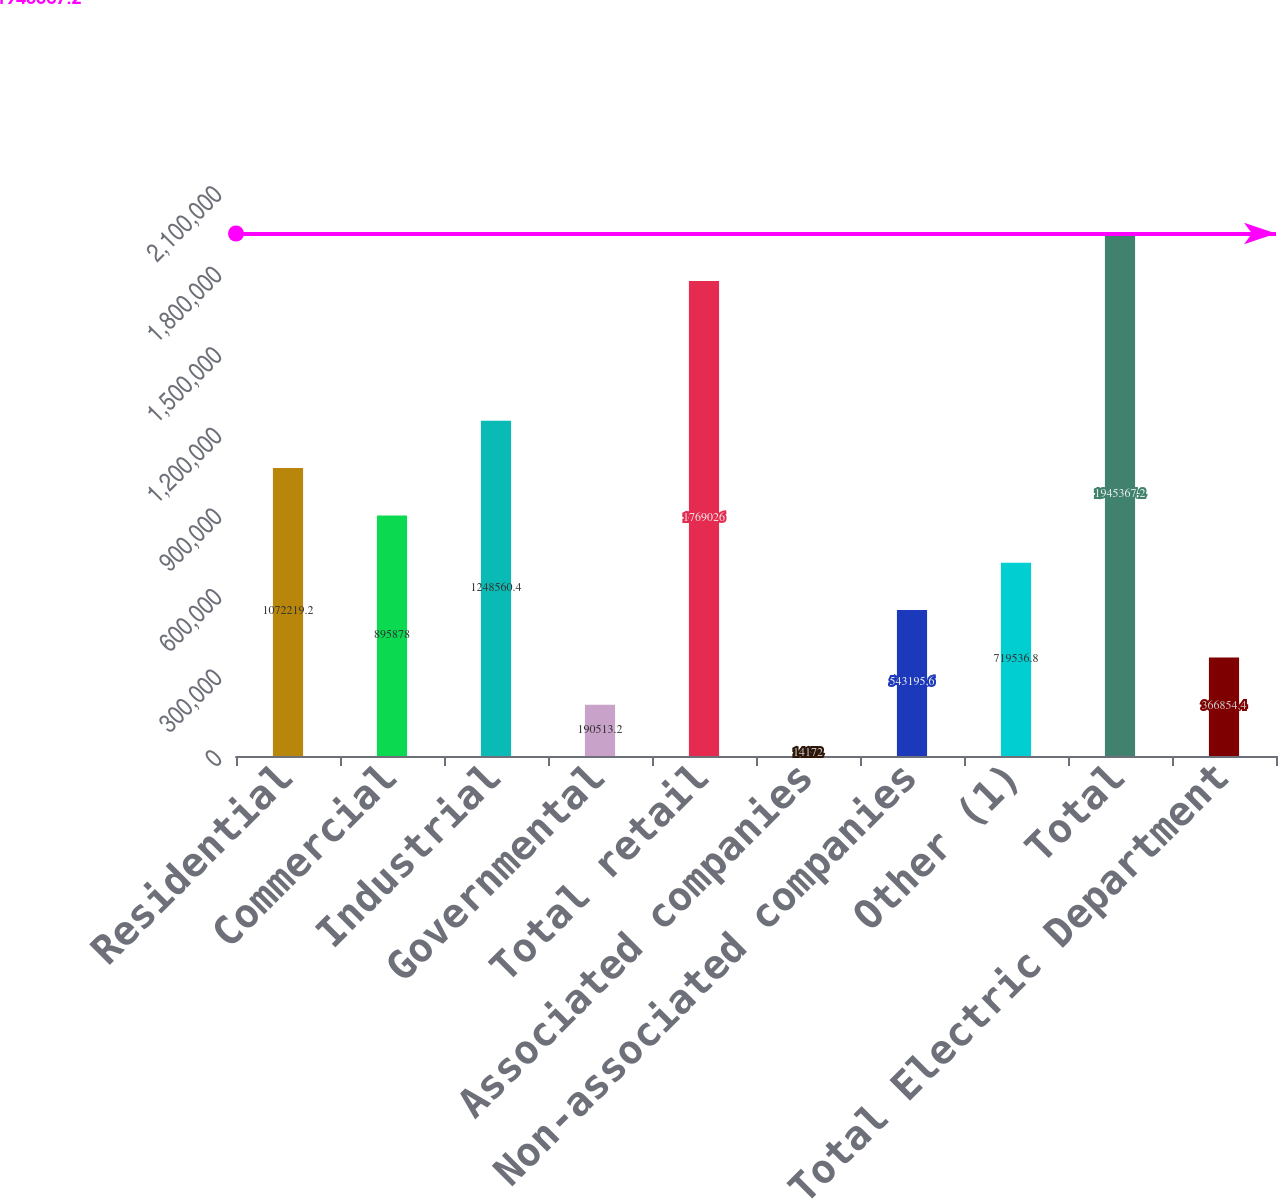Convert chart to OTSL. <chart><loc_0><loc_0><loc_500><loc_500><bar_chart><fcel>Residential<fcel>Commercial<fcel>Industrial<fcel>Governmental<fcel>Total retail<fcel>Associated companies<fcel>Non-associated companies<fcel>Other (1)<fcel>Total<fcel>Total Electric Department<nl><fcel>1.07222e+06<fcel>895878<fcel>1.24856e+06<fcel>190513<fcel>1.76903e+06<fcel>14172<fcel>543196<fcel>719537<fcel>1.94537e+06<fcel>366854<nl></chart> 